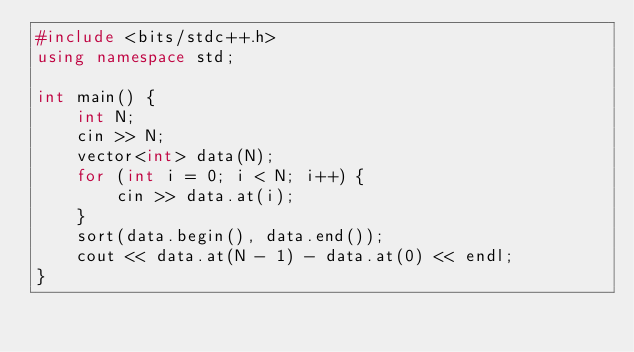Convert code to text. <code><loc_0><loc_0><loc_500><loc_500><_C++_>#include <bits/stdc++.h>
using namespace std;

int main() {
    int N;
    cin >> N;
    vector<int> data(N);
    for (int i = 0; i < N; i++) {
        cin >> data.at(i);
    }
    sort(data.begin(), data.end());
    cout << data.at(N - 1) - data.at(0) << endl;
}
</code> 